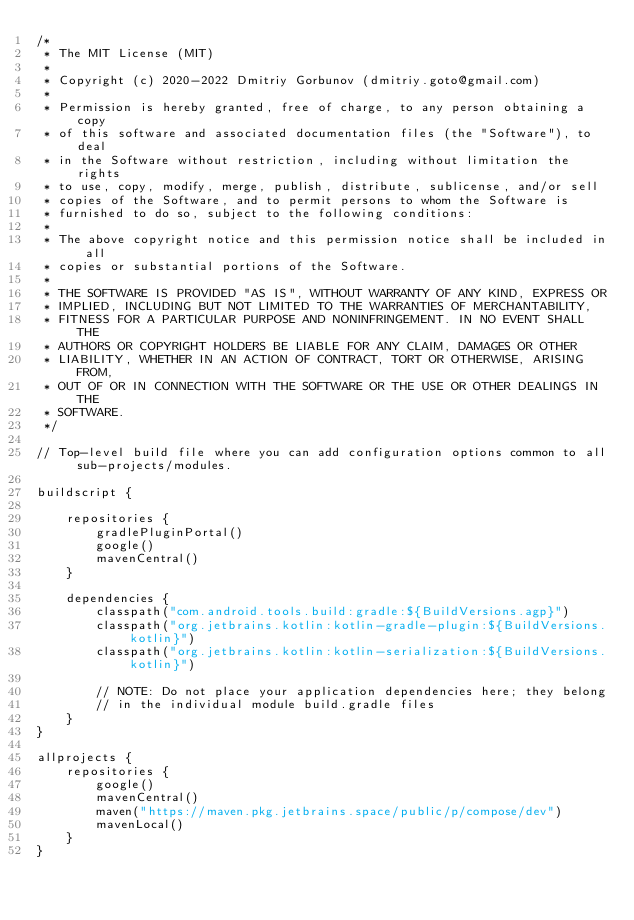<code> <loc_0><loc_0><loc_500><loc_500><_Kotlin_>/*
 * The MIT License (MIT)
 *
 * Copyright (c) 2020-2022 Dmitriy Gorbunov (dmitriy.goto@gmail.com)
 *
 * Permission is hereby granted, free of charge, to any person obtaining a copy
 * of this software and associated documentation files (the "Software"), to deal
 * in the Software without restriction, including without limitation the rights
 * to use, copy, modify, merge, publish, distribute, sublicense, and/or sell
 * copies of the Software, and to permit persons to whom the Software is
 * furnished to do so, subject to the following conditions:
 *
 * The above copyright notice and this permission notice shall be included in all
 * copies or substantial portions of the Software.
 *
 * THE SOFTWARE IS PROVIDED "AS IS", WITHOUT WARRANTY OF ANY KIND, EXPRESS OR
 * IMPLIED, INCLUDING BUT NOT LIMITED TO THE WARRANTIES OF MERCHANTABILITY,
 * FITNESS FOR A PARTICULAR PURPOSE AND NONINFRINGEMENT. IN NO EVENT SHALL THE
 * AUTHORS OR COPYRIGHT HOLDERS BE LIABLE FOR ANY CLAIM, DAMAGES OR OTHER
 * LIABILITY, WHETHER IN AN ACTION OF CONTRACT, TORT OR OTHERWISE, ARISING FROM,
 * OUT OF OR IN CONNECTION WITH THE SOFTWARE OR THE USE OR OTHER DEALINGS IN THE
 * SOFTWARE.
 */

// Top-level build file where you can add configuration options common to all sub-projects/modules.

buildscript {

    repositories {
        gradlePluginPortal()
        google()
        mavenCentral()
    }

    dependencies {
        classpath("com.android.tools.build:gradle:${BuildVersions.agp}")
        classpath("org.jetbrains.kotlin:kotlin-gradle-plugin:${BuildVersions.kotlin}")
        classpath("org.jetbrains.kotlin:kotlin-serialization:${BuildVersions.kotlin}")

        // NOTE: Do not place your application dependencies here; they belong
        // in the individual module build.gradle files
    }
}

allprojects {
    repositories {
        google()
        mavenCentral()
        maven("https://maven.pkg.jetbrains.space/public/p/compose/dev")
        mavenLocal()
    }
}
</code> 